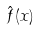Convert formula to latex. <formula><loc_0><loc_0><loc_500><loc_500>\hat { f } ( x )</formula> 